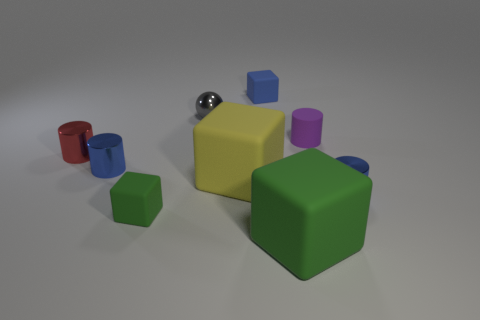There is a green thing that is the same size as the red shiny cylinder; what is its shape?
Offer a terse response. Cube. How many objects are small blue things in front of the small purple matte object or matte objects in front of the ball?
Make the answer very short. 6. There is a green cube that is the same size as the purple object; what is its material?
Offer a very short reply. Rubber. What number of other things are made of the same material as the big green object?
Make the answer very short. 4. Is the number of cylinders that are on the left side of the gray object the same as the number of small green objects that are left of the small green matte object?
Keep it short and to the point. No. What number of gray things are balls or rubber objects?
Make the answer very short. 1. There is a tiny sphere; is its color the same as the rubber thing that is to the left of the sphere?
Make the answer very short. No. Is the number of big brown shiny cubes less than the number of blue cylinders?
Offer a terse response. Yes. How many small blue metal cylinders are in front of the small blue cylinder that is on the left side of the tiny blue metallic cylinder that is on the right side of the small metallic ball?
Make the answer very short. 1. There is a thing that is on the right side of the small purple matte cylinder; what is its size?
Offer a very short reply. Small. 